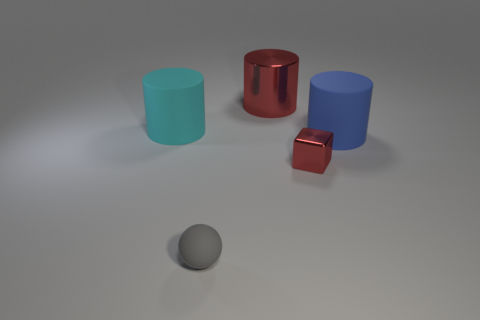Is the large metal cylinder the same color as the matte sphere?
Give a very brief answer. No. Are there fewer small red metal things in front of the tiny ball than red shiny things in front of the large metal cylinder?
Your answer should be compact. Yes. The tiny matte object has what color?
Offer a very short reply. Gray. How many small metallic objects have the same color as the block?
Make the answer very short. 0. Are there any big matte objects left of the large cyan matte cylinder?
Ensure brevity in your answer.  No. Are there the same number of cyan cylinders behind the blue matte cylinder and big red metal cylinders that are on the right side of the large red metal cylinder?
Ensure brevity in your answer.  No. There is a red metal thing that is in front of the blue matte cylinder; does it have the same size as the red thing that is behind the big cyan matte object?
Your response must be concise. No. There is a big matte object that is to the left of the red object that is behind the big rubber thing on the right side of the cyan matte cylinder; what shape is it?
Offer a terse response. Cylinder. Is there anything else that is the same material as the blue thing?
Offer a very short reply. Yes. The cyan rubber thing that is the same shape as the big blue thing is what size?
Offer a terse response. Large. 